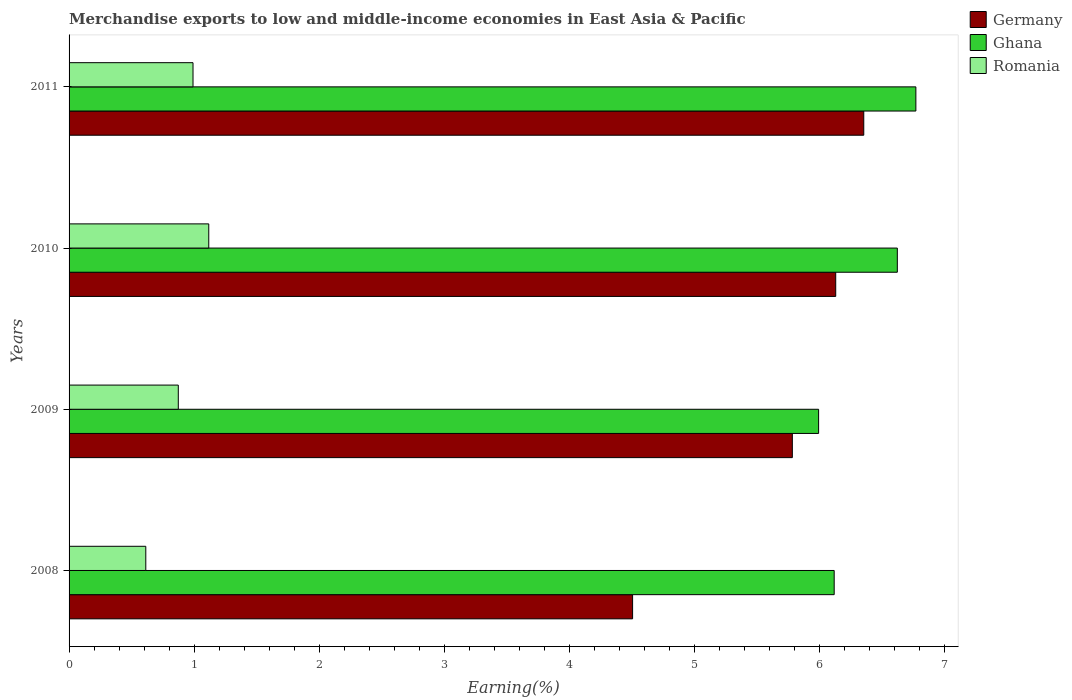How many different coloured bars are there?
Offer a very short reply. 3. How many groups of bars are there?
Offer a terse response. 4. How many bars are there on the 4th tick from the top?
Provide a succinct answer. 3. How many bars are there on the 3rd tick from the bottom?
Ensure brevity in your answer.  3. What is the label of the 3rd group of bars from the top?
Offer a terse response. 2009. What is the percentage of amount earned from merchandise exports in Romania in 2009?
Provide a succinct answer. 0.87. Across all years, what is the maximum percentage of amount earned from merchandise exports in Germany?
Provide a succinct answer. 6.35. Across all years, what is the minimum percentage of amount earned from merchandise exports in Ghana?
Give a very brief answer. 5.99. In which year was the percentage of amount earned from merchandise exports in Germany maximum?
Your answer should be compact. 2011. In which year was the percentage of amount earned from merchandise exports in Romania minimum?
Provide a succinct answer. 2008. What is the total percentage of amount earned from merchandise exports in Ghana in the graph?
Your response must be concise. 25.49. What is the difference between the percentage of amount earned from merchandise exports in Romania in 2008 and that in 2009?
Ensure brevity in your answer.  -0.26. What is the difference between the percentage of amount earned from merchandise exports in Germany in 2010 and the percentage of amount earned from merchandise exports in Romania in 2008?
Your response must be concise. 5.51. What is the average percentage of amount earned from merchandise exports in Romania per year?
Offer a terse response. 0.9. In the year 2009, what is the difference between the percentage of amount earned from merchandise exports in Ghana and percentage of amount earned from merchandise exports in Romania?
Provide a succinct answer. 5.12. In how many years, is the percentage of amount earned from merchandise exports in Ghana greater than 3.2 %?
Ensure brevity in your answer.  4. What is the ratio of the percentage of amount earned from merchandise exports in Ghana in 2009 to that in 2010?
Provide a short and direct response. 0.9. What is the difference between the highest and the second highest percentage of amount earned from merchandise exports in Ghana?
Your answer should be very brief. 0.15. What is the difference between the highest and the lowest percentage of amount earned from merchandise exports in Germany?
Your response must be concise. 1.85. What does the 1st bar from the top in 2009 represents?
Make the answer very short. Romania. What does the 2nd bar from the bottom in 2011 represents?
Give a very brief answer. Ghana. What is the difference between two consecutive major ticks on the X-axis?
Provide a succinct answer. 1. Does the graph contain any zero values?
Ensure brevity in your answer.  No. Does the graph contain grids?
Offer a very short reply. No. Where does the legend appear in the graph?
Offer a terse response. Top right. How many legend labels are there?
Make the answer very short. 3. What is the title of the graph?
Make the answer very short. Merchandise exports to low and middle-income economies in East Asia & Pacific. What is the label or title of the X-axis?
Your response must be concise. Earning(%). What is the label or title of the Y-axis?
Provide a succinct answer. Years. What is the Earning(%) of Germany in 2008?
Provide a succinct answer. 4.5. What is the Earning(%) of Ghana in 2008?
Your answer should be compact. 6.12. What is the Earning(%) of Romania in 2008?
Your answer should be compact. 0.61. What is the Earning(%) of Germany in 2009?
Make the answer very short. 5.78. What is the Earning(%) of Ghana in 2009?
Make the answer very short. 5.99. What is the Earning(%) in Romania in 2009?
Make the answer very short. 0.87. What is the Earning(%) of Germany in 2010?
Provide a short and direct response. 6.13. What is the Earning(%) of Ghana in 2010?
Your answer should be very brief. 6.62. What is the Earning(%) of Romania in 2010?
Make the answer very short. 1.12. What is the Earning(%) in Germany in 2011?
Provide a short and direct response. 6.35. What is the Earning(%) in Ghana in 2011?
Provide a succinct answer. 6.77. What is the Earning(%) of Romania in 2011?
Provide a short and direct response. 0.99. Across all years, what is the maximum Earning(%) in Germany?
Your response must be concise. 6.35. Across all years, what is the maximum Earning(%) of Ghana?
Your answer should be compact. 6.77. Across all years, what is the maximum Earning(%) of Romania?
Ensure brevity in your answer.  1.12. Across all years, what is the minimum Earning(%) of Germany?
Your answer should be very brief. 4.5. Across all years, what is the minimum Earning(%) in Ghana?
Your answer should be compact. 5.99. Across all years, what is the minimum Earning(%) in Romania?
Keep it short and to the point. 0.61. What is the total Earning(%) in Germany in the graph?
Offer a terse response. 22.76. What is the total Earning(%) of Ghana in the graph?
Your answer should be compact. 25.49. What is the total Earning(%) in Romania in the graph?
Ensure brevity in your answer.  3.59. What is the difference between the Earning(%) of Germany in 2008 and that in 2009?
Offer a very short reply. -1.28. What is the difference between the Earning(%) of Ghana in 2008 and that in 2009?
Provide a short and direct response. 0.12. What is the difference between the Earning(%) of Romania in 2008 and that in 2009?
Give a very brief answer. -0.26. What is the difference between the Earning(%) in Germany in 2008 and that in 2010?
Offer a terse response. -1.62. What is the difference between the Earning(%) of Ghana in 2008 and that in 2010?
Offer a very short reply. -0.5. What is the difference between the Earning(%) of Romania in 2008 and that in 2010?
Ensure brevity in your answer.  -0.5. What is the difference between the Earning(%) in Germany in 2008 and that in 2011?
Your answer should be compact. -1.85. What is the difference between the Earning(%) in Ghana in 2008 and that in 2011?
Your answer should be very brief. -0.65. What is the difference between the Earning(%) in Romania in 2008 and that in 2011?
Give a very brief answer. -0.38. What is the difference between the Earning(%) in Germany in 2009 and that in 2010?
Provide a succinct answer. -0.35. What is the difference between the Earning(%) of Ghana in 2009 and that in 2010?
Provide a succinct answer. -0.63. What is the difference between the Earning(%) in Romania in 2009 and that in 2010?
Offer a very short reply. -0.24. What is the difference between the Earning(%) of Germany in 2009 and that in 2011?
Give a very brief answer. -0.57. What is the difference between the Earning(%) in Ghana in 2009 and that in 2011?
Your answer should be very brief. -0.78. What is the difference between the Earning(%) of Romania in 2009 and that in 2011?
Provide a succinct answer. -0.12. What is the difference between the Earning(%) of Germany in 2010 and that in 2011?
Your response must be concise. -0.22. What is the difference between the Earning(%) in Ghana in 2010 and that in 2011?
Keep it short and to the point. -0.15. What is the difference between the Earning(%) in Romania in 2010 and that in 2011?
Offer a terse response. 0.13. What is the difference between the Earning(%) of Germany in 2008 and the Earning(%) of Ghana in 2009?
Make the answer very short. -1.49. What is the difference between the Earning(%) of Germany in 2008 and the Earning(%) of Romania in 2009?
Your answer should be compact. 3.63. What is the difference between the Earning(%) in Ghana in 2008 and the Earning(%) in Romania in 2009?
Your response must be concise. 5.24. What is the difference between the Earning(%) in Germany in 2008 and the Earning(%) in Ghana in 2010?
Offer a very short reply. -2.12. What is the difference between the Earning(%) of Germany in 2008 and the Earning(%) of Romania in 2010?
Your response must be concise. 3.39. What is the difference between the Earning(%) in Ghana in 2008 and the Earning(%) in Romania in 2010?
Make the answer very short. 5. What is the difference between the Earning(%) in Germany in 2008 and the Earning(%) in Ghana in 2011?
Your response must be concise. -2.26. What is the difference between the Earning(%) of Germany in 2008 and the Earning(%) of Romania in 2011?
Provide a short and direct response. 3.51. What is the difference between the Earning(%) in Ghana in 2008 and the Earning(%) in Romania in 2011?
Provide a short and direct response. 5.12. What is the difference between the Earning(%) of Germany in 2009 and the Earning(%) of Ghana in 2010?
Provide a succinct answer. -0.84. What is the difference between the Earning(%) in Germany in 2009 and the Earning(%) in Romania in 2010?
Make the answer very short. 4.66. What is the difference between the Earning(%) in Ghana in 2009 and the Earning(%) in Romania in 2010?
Your answer should be compact. 4.87. What is the difference between the Earning(%) of Germany in 2009 and the Earning(%) of Ghana in 2011?
Provide a succinct answer. -0.99. What is the difference between the Earning(%) of Germany in 2009 and the Earning(%) of Romania in 2011?
Your response must be concise. 4.79. What is the difference between the Earning(%) of Ghana in 2009 and the Earning(%) of Romania in 2011?
Ensure brevity in your answer.  5. What is the difference between the Earning(%) of Germany in 2010 and the Earning(%) of Ghana in 2011?
Make the answer very short. -0.64. What is the difference between the Earning(%) of Germany in 2010 and the Earning(%) of Romania in 2011?
Provide a succinct answer. 5.14. What is the difference between the Earning(%) in Ghana in 2010 and the Earning(%) in Romania in 2011?
Offer a terse response. 5.63. What is the average Earning(%) of Germany per year?
Keep it short and to the point. 5.69. What is the average Earning(%) of Ghana per year?
Give a very brief answer. 6.37. What is the average Earning(%) in Romania per year?
Offer a very short reply. 0.9. In the year 2008, what is the difference between the Earning(%) in Germany and Earning(%) in Ghana?
Provide a succinct answer. -1.61. In the year 2008, what is the difference between the Earning(%) of Germany and Earning(%) of Romania?
Ensure brevity in your answer.  3.89. In the year 2008, what is the difference between the Earning(%) of Ghana and Earning(%) of Romania?
Provide a succinct answer. 5.5. In the year 2009, what is the difference between the Earning(%) in Germany and Earning(%) in Ghana?
Your answer should be compact. -0.21. In the year 2009, what is the difference between the Earning(%) in Germany and Earning(%) in Romania?
Offer a terse response. 4.91. In the year 2009, what is the difference between the Earning(%) of Ghana and Earning(%) of Romania?
Offer a very short reply. 5.12. In the year 2010, what is the difference between the Earning(%) in Germany and Earning(%) in Ghana?
Offer a terse response. -0.49. In the year 2010, what is the difference between the Earning(%) in Germany and Earning(%) in Romania?
Ensure brevity in your answer.  5.01. In the year 2010, what is the difference between the Earning(%) in Ghana and Earning(%) in Romania?
Provide a short and direct response. 5.5. In the year 2011, what is the difference between the Earning(%) in Germany and Earning(%) in Ghana?
Keep it short and to the point. -0.42. In the year 2011, what is the difference between the Earning(%) of Germany and Earning(%) of Romania?
Offer a terse response. 5.36. In the year 2011, what is the difference between the Earning(%) of Ghana and Earning(%) of Romania?
Your response must be concise. 5.78. What is the ratio of the Earning(%) of Germany in 2008 to that in 2009?
Ensure brevity in your answer.  0.78. What is the ratio of the Earning(%) of Ghana in 2008 to that in 2009?
Provide a succinct answer. 1.02. What is the ratio of the Earning(%) in Romania in 2008 to that in 2009?
Give a very brief answer. 0.7. What is the ratio of the Earning(%) of Germany in 2008 to that in 2010?
Your answer should be very brief. 0.73. What is the ratio of the Earning(%) in Ghana in 2008 to that in 2010?
Keep it short and to the point. 0.92. What is the ratio of the Earning(%) in Romania in 2008 to that in 2010?
Provide a succinct answer. 0.55. What is the ratio of the Earning(%) of Germany in 2008 to that in 2011?
Keep it short and to the point. 0.71. What is the ratio of the Earning(%) in Ghana in 2008 to that in 2011?
Your answer should be compact. 0.9. What is the ratio of the Earning(%) of Romania in 2008 to that in 2011?
Your answer should be compact. 0.62. What is the ratio of the Earning(%) in Germany in 2009 to that in 2010?
Your response must be concise. 0.94. What is the ratio of the Earning(%) of Ghana in 2009 to that in 2010?
Your answer should be compact. 0.91. What is the ratio of the Earning(%) of Romania in 2009 to that in 2010?
Your answer should be compact. 0.78. What is the ratio of the Earning(%) of Germany in 2009 to that in 2011?
Your response must be concise. 0.91. What is the ratio of the Earning(%) of Ghana in 2009 to that in 2011?
Offer a very short reply. 0.89. What is the ratio of the Earning(%) of Romania in 2009 to that in 2011?
Ensure brevity in your answer.  0.88. What is the ratio of the Earning(%) in Germany in 2010 to that in 2011?
Your response must be concise. 0.96. What is the ratio of the Earning(%) in Ghana in 2010 to that in 2011?
Your answer should be very brief. 0.98. What is the ratio of the Earning(%) of Romania in 2010 to that in 2011?
Give a very brief answer. 1.13. What is the difference between the highest and the second highest Earning(%) in Germany?
Offer a terse response. 0.22. What is the difference between the highest and the second highest Earning(%) of Ghana?
Offer a terse response. 0.15. What is the difference between the highest and the second highest Earning(%) in Romania?
Your answer should be compact. 0.13. What is the difference between the highest and the lowest Earning(%) of Germany?
Provide a short and direct response. 1.85. What is the difference between the highest and the lowest Earning(%) in Ghana?
Your response must be concise. 0.78. What is the difference between the highest and the lowest Earning(%) of Romania?
Give a very brief answer. 0.5. 